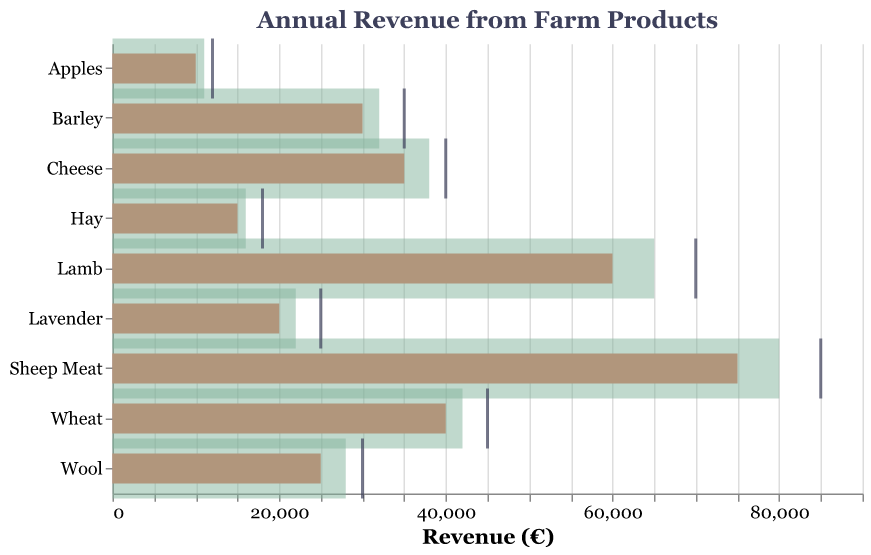Which product generated the highest actual revenue? By looking at the length of the orange bars, we can see that "Sheep Meat" has the highest actual revenue among all products.
Answer: Sheep Meat Is the actual revenue for Lavender above or below the average revenue? The orange bar for Lavender is shorter than the green semi-transparent bar, indicating that the actual revenue is below the average revenue.
Answer: Below Which product's actual revenue is closest to its target revenue? By comparing the length of the orange bars to the position of the dark dashes, **Wool** has the closest actual revenue to its target revenue.
Answer: Wool Which farm product has the largest gap between its target revenue and actual revenue? By observing the difference between the tick marks and the orange bars, the product "Sheep Meat" has the largest gap.
Answer: Sheep Meat What is the average revenue for Cheese? By looking at the position of the green semi-transparent bar for Cheese, the average revenue is located at €38,000.
Answer: 38,000 Does the actual revenue for Barley meet its target? The orange bar for Barley is shorter than the position of the dark tick mark, implying the actual revenue did not meet the target revenue.
Answer: No Which product had the lowest actual revenue? The shortest orange bar belongs to "Apples", indicating the lowest actual revenue.
Answer: Apples How much more revenue was needed for Hay to meet its target? The target revenue for Hay is €18,000 and the actual revenue is €15,000. The difference is €18,000 - €15,000 = €3,000.
Answer: 3,000 Which product has an actual revenue that exceeds the average revenue for that product? By observing the orange bars relative to the green semi-transparent bars, none of the products have actual revenues exceeding their average revenues.
Answer: None How much actual revenue did Wool generate? The actual revenue for Wool is visually indicated by the length of the orange bar, reaching €25,000.
Answer: 25,000 